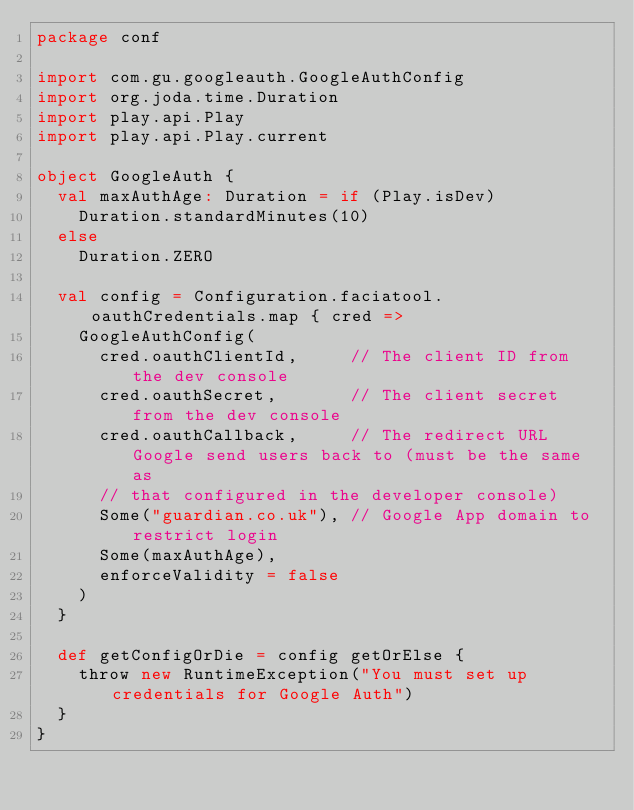Convert code to text. <code><loc_0><loc_0><loc_500><loc_500><_Scala_>package conf

import com.gu.googleauth.GoogleAuthConfig
import org.joda.time.Duration
import play.api.Play
import play.api.Play.current

object GoogleAuth {
  val maxAuthAge: Duration = if (Play.isDev)
    Duration.standardMinutes(10)
  else
    Duration.ZERO

  val config = Configuration.faciatool.oauthCredentials.map { cred =>
    GoogleAuthConfig(
      cred.oauthClientId,     // The client ID from the dev console
      cred.oauthSecret,       // The client secret from the dev console
      cred.oauthCallback,     // The redirect URL Google send users back to (must be the same as
      // that configured in the developer console)
      Some("guardian.co.uk"), // Google App domain to restrict login
      Some(maxAuthAge),
      enforceValidity = false
    )
  }

  def getConfigOrDie = config getOrElse {
    throw new RuntimeException("You must set up credentials for Google Auth")
  }
}
</code> 